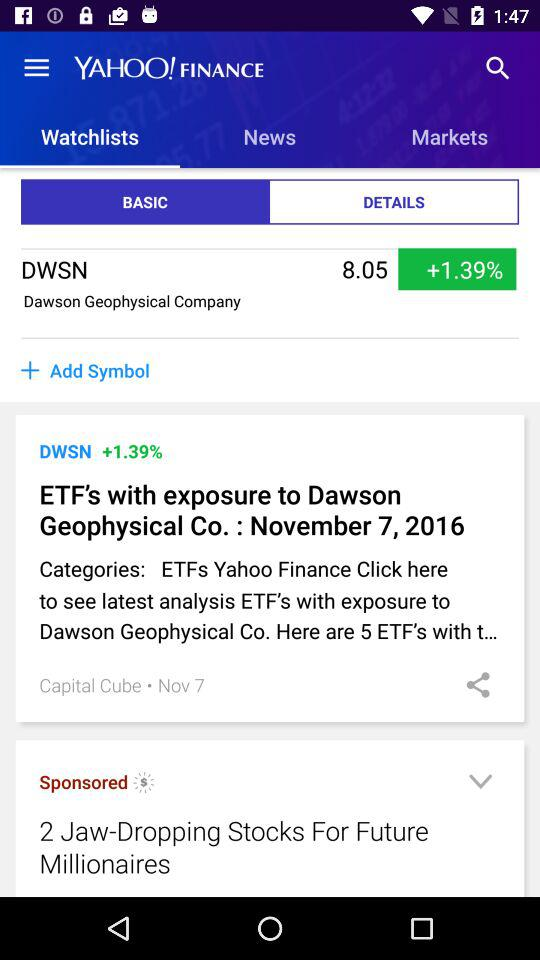What is the publication date of the article? The publication date of the article is Nov 7. 